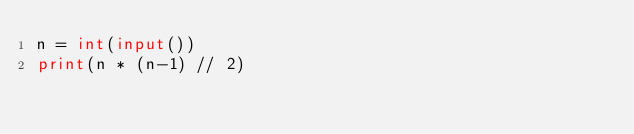<code> <loc_0><loc_0><loc_500><loc_500><_Python_>n = int(input())
print(n * (n-1) // 2)</code> 